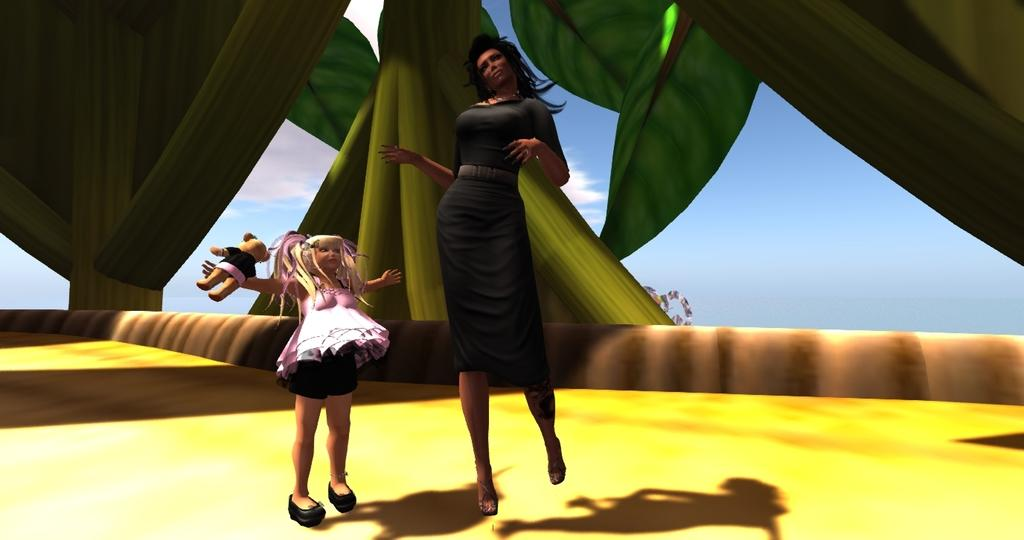Who are the characters in the animation? There is a woman and a girl in the animation. What else can be seen in the animation besides the characters? There is a toy in the animation. How many cents does the girl have in the animation? There is no mention of money or cents in the animation, so it cannot be determined. 